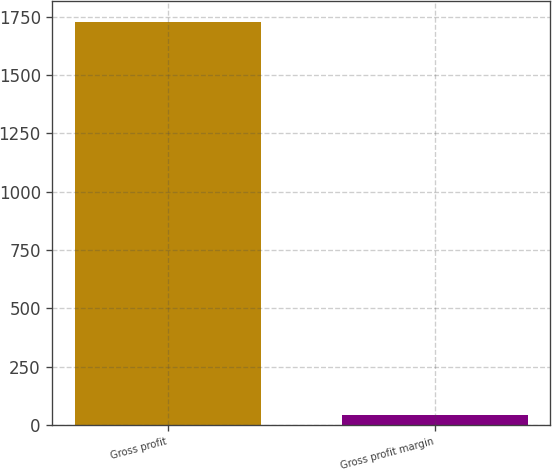Convert chart to OTSL. <chart><loc_0><loc_0><loc_500><loc_500><bar_chart><fcel>Gross profit<fcel>Gross profit margin<nl><fcel>1730.2<fcel>40.8<nl></chart> 